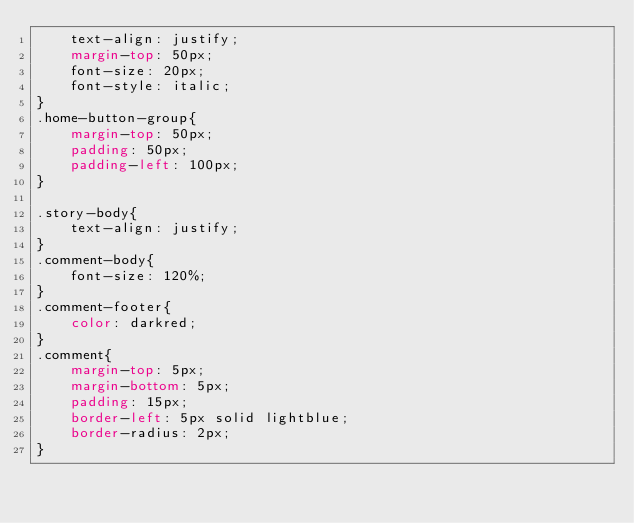<code> <loc_0><loc_0><loc_500><loc_500><_CSS_>    text-align: justify;
    margin-top: 50px;
    font-size: 20px;
    font-style: italic;
}
.home-button-group{
    margin-top: 50px;
    padding: 50px;
    padding-left: 100px;
}

.story-body{
    text-align: justify;    
}
.comment-body{
    font-size: 120%;
}
.comment-footer{
    color: darkred;
}
.comment{
    margin-top: 5px; 
    margin-bottom: 5px; 
    padding: 15px;
    border-left: 5px solid lightblue;
    border-radius: 2px;
}

</code> 